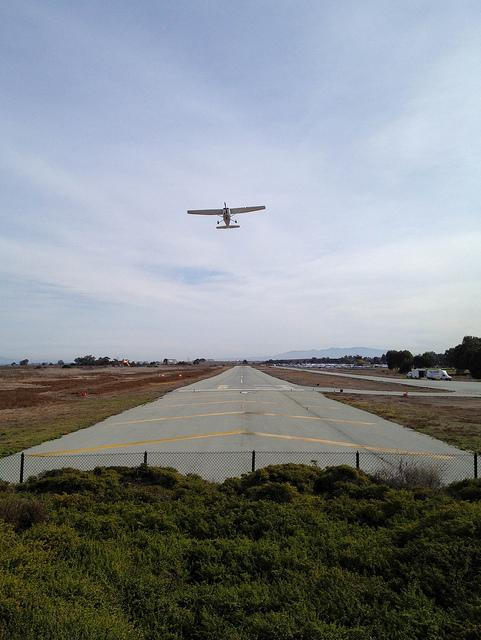What is the plane pictured above doing? taking off 